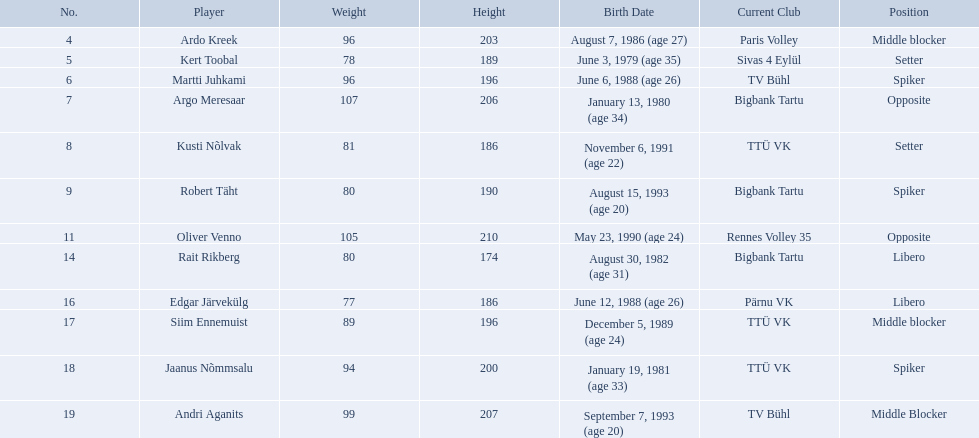Who are all of the players? Ardo Kreek, Kert Toobal, Martti Juhkami, Argo Meresaar, Kusti Nõlvak, Robert Täht, Oliver Venno, Rait Rikberg, Edgar Järvekülg, Siim Ennemuist, Jaanus Nõmmsalu, Andri Aganits. How tall are they? 203, 189, 196, 206, 186, 190, 210, 174, 186, 196, 200, 207. And which player is tallest? Oliver Venno. 